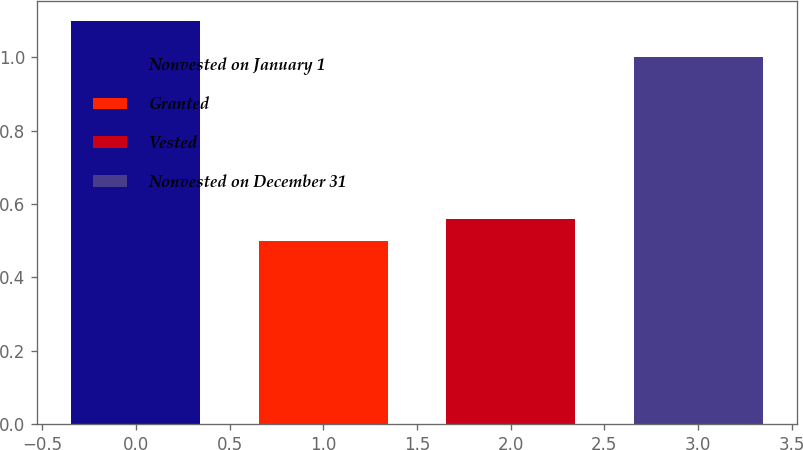Convert chart. <chart><loc_0><loc_0><loc_500><loc_500><bar_chart><fcel>Nonvested on January 1<fcel>Granted<fcel>Vested<fcel>Nonvested on December 31<nl><fcel>1.1<fcel>0.5<fcel>0.56<fcel>1<nl></chart> 